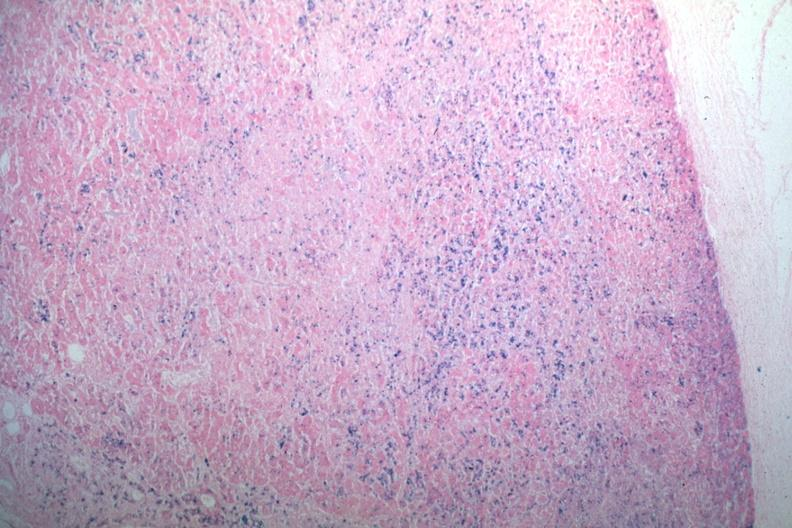s hemochromatosis present?
Answer the question using a single word or phrase. Yes 